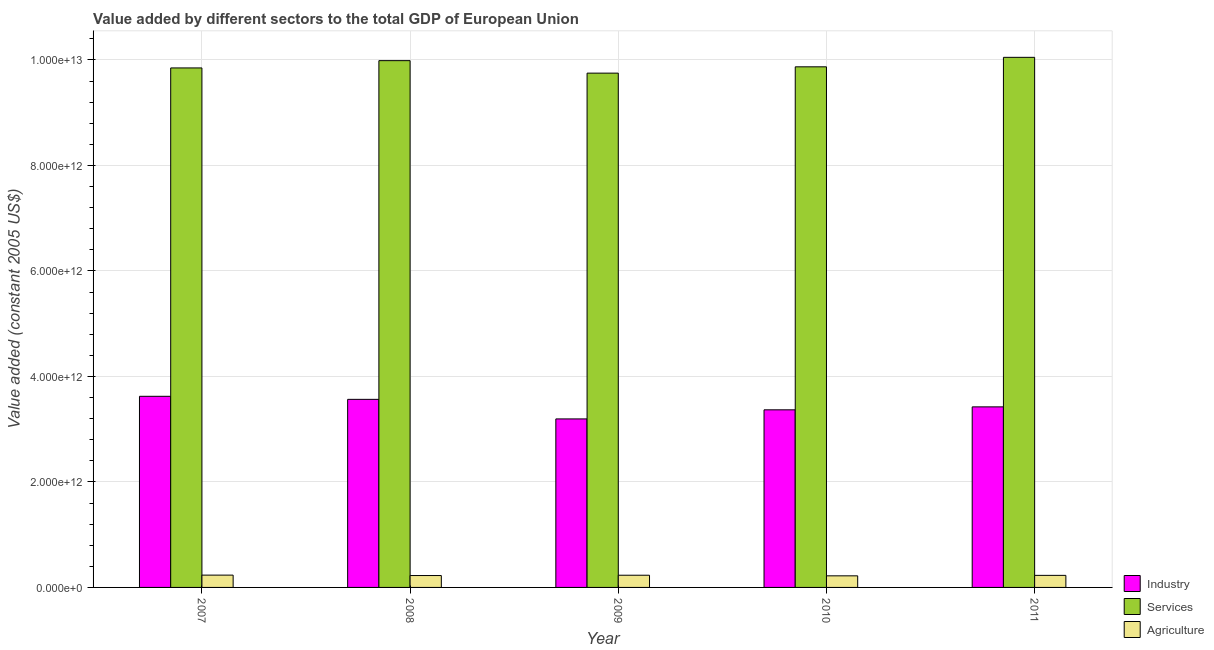Are the number of bars per tick equal to the number of legend labels?
Keep it short and to the point. Yes. How many bars are there on the 2nd tick from the left?
Make the answer very short. 3. What is the label of the 4th group of bars from the left?
Make the answer very short. 2010. What is the value added by industrial sector in 2009?
Provide a short and direct response. 3.19e+12. Across all years, what is the maximum value added by industrial sector?
Give a very brief answer. 3.62e+12. Across all years, what is the minimum value added by services?
Make the answer very short. 9.75e+12. In which year was the value added by agricultural sector minimum?
Keep it short and to the point. 2010. What is the total value added by agricultural sector in the graph?
Keep it short and to the point. 1.14e+12. What is the difference between the value added by industrial sector in 2007 and that in 2011?
Your answer should be compact. 2.00e+11. What is the difference between the value added by services in 2011 and the value added by agricultural sector in 2008?
Offer a very short reply. 6.28e+1. What is the average value added by services per year?
Keep it short and to the point. 9.90e+12. What is the ratio of the value added by industrial sector in 2008 to that in 2009?
Provide a succinct answer. 1.12. Is the difference between the value added by agricultural sector in 2008 and 2009 greater than the difference between the value added by services in 2008 and 2009?
Provide a short and direct response. No. What is the difference between the highest and the second highest value added by industrial sector?
Your answer should be compact. 5.77e+1. What is the difference between the highest and the lowest value added by agricultural sector?
Your response must be concise. 1.38e+1. In how many years, is the value added by industrial sector greater than the average value added by industrial sector taken over all years?
Your answer should be compact. 2. What does the 2nd bar from the left in 2009 represents?
Your response must be concise. Services. What does the 3rd bar from the right in 2009 represents?
Provide a short and direct response. Industry. Is it the case that in every year, the sum of the value added by industrial sector and value added by services is greater than the value added by agricultural sector?
Your answer should be compact. Yes. Are all the bars in the graph horizontal?
Your answer should be very brief. No. What is the difference between two consecutive major ticks on the Y-axis?
Ensure brevity in your answer.  2.00e+12. Are the values on the major ticks of Y-axis written in scientific E-notation?
Provide a succinct answer. Yes. Does the graph contain any zero values?
Make the answer very short. No. Where does the legend appear in the graph?
Provide a succinct answer. Bottom right. How are the legend labels stacked?
Ensure brevity in your answer.  Vertical. What is the title of the graph?
Give a very brief answer. Value added by different sectors to the total GDP of European Union. What is the label or title of the X-axis?
Your answer should be very brief. Year. What is the label or title of the Y-axis?
Your response must be concise. Value added (constant 2005 US$). What is the Value added (constant 2005 US$) of Industry in 2007?
Your response must be concise. 3.62e+12. What is the Value added (constant 2005 US$) in Services in 2007?
Give a very brief answer. 9.85e+12. What is the Value added (constant 2005 US$) in Agriculture in 2007?
Your answer should be very brief. 2.33e+11. What is the Value added (constant 2005 US$) of Industry in 2008?
Offer a terse response. 3.57e+12. What is the Value added (constant 2005 US$) of Services in 2008?
Your response must be concise. 9.99e+12. What is the Value added (constant 2005 US$) in Agriculture in 2008?
Ensure brevity in your answer.  2.25e+11. What is the Value added (constant 2005 US$) in Industry in 2009?
Your answer should be very brief. 3.19e+12. What is the Value added (constant 2005 US$) in Services in 2009?
Your response must be concise. 9.75e+12. What is the Value added (constant 2005 US$) in Agriculture in 2009?
Offer a terse response. 2.31e+11. What is the Value added (constant 2005 US$) in Industry in 2010?
Your answer should be very brief. 3.37e+12. What is the Value added (constant 2005 US$) of Services in 2010?
Provide a short and direct response. 9.87e+12. What is the Value added (constant 2005 US$) in Agriculture in 2010?
Offer a terse response. 2.20e+11. What is the Value added (constant 2005 US$) of Industry in 2011?
Keep it short and to the point. 3.42e+12. What is the Value added (constant 2005 US$) in Services in 2011?
Provide a succinct answer. 1.01e+13. What is the Value added (constant 2005 US$) of Agriculture in 2011?
Your answer should be very brief. 2.29e+11. Across all years, what is the maximum Value added (constant 2005 US$) in Industry?
Your answer should be very brief. 3.62e+12. Across all years, what is the maximum Value added (constant 2005 US$) of Services?
Ensure brevity in your answer.  1.01e+13. Across all years, what is the maximum Value added (constant 2005 US$) in Agriculture?
Offer a terse response. 2.33e+11. Across all years, what is the minimum Value added (constant 2005 US$) of Industry?
Keep it short and to the point. 3.19e+12. Across all years, what is the minimum Value added (constant 2005 US$) of Services?
Keep it short and to the point. 9.75e+12. Across all years, what is the minimum Value added (constant 2005 US$) in Agriculture?
Your answer should be very brief. 2.20e+11. What is the total Value added (constant 2005 US$) of Industry in the graph?
Ensure brevity in your answer.  1.72e+13. What is the total Value added (constant 2005 US$) in Services in the graph?
Keep it short and to the point. 4.95e+13. What is the total Value added (constant 2005 US$) in Agriculture in the graph?
Your answer should be very brief. 1.14e+12. What is the difference between the Value added (constant 2005 US$) of Industry in 2007 and that in 2008?
Make the answer very short. 5.77e+1. What is the difference between the Value added (constant 2005 US$) in Services in 2007 and that in 2008?
Your answer should be very brief. -1.38e+11. What is the difference between the Value added (constant 2005 US$) in Agriculture in 2007 and that in 2008?
Make the answer very short. 8.12e+09. What is the difference between the Value added (constant 2005 US$) in Industry in 2007 and that in 2009?
Keep it short and to the point. 4.29e+11. What is the difference between the Value added (constant 2005 US$) of Services in 2007 and that in 2009?
Make the answer very short. 9.87e+1. What is the difference between the Value added (constant 2005 US$) in Agriculture in 2007 and that in 2009?
Your answer should be compact. 2.23e+09. What is the difference between the Value added (constant 2005 US$) in Industry in 2007 and that in 2010?
Ensure brevity in your answer.  2.56e+11. What is the difference between the Value added (constant 2005 US$) in Services in 2007 and that in 2010?
Your answer should be very brief. -2.10e+1. What is the difference between the Value added (constant 2005 US$) of Agriculture in 2007 and that in 2010?
Keep it short and to the point. 1.38e+1. What is the difference between the Value added (constant 2005 US$) of Industry in 2007 and that in 2011?
Provide a short and direct response. 2.00e+11. What is the difference between the Value added (constant 2005 US$) of Services in 2007 and that in 2011?
Keep it short and to the point. -2.01e+11. What is the difference between the Value added (constant 2005 US$) in Agriculture in 2007 and that in 2011?
Provide a short and direct response. 4.87e+09. What is the difference between the Value added (constant 2005 US$) of Industry in 2008 and that in 2009?
Provide a succinct answer. 3.71e+11. What is the difference between the Value added (constant 2005 US$) of Services in 2008 and that in 2009?
Make the answer very short. 2.37e+11. What is the difference between the Value added (constant 2005 US$) of Agriculture in 2008 and that in 2009?
Keep it short and to the point. -5.89e+09. What is the difference between the Value added (constant 2005 US$) in Industry in 2008 and that in 2010?
Provide a short and direct response. 1.98e+11. What is the difference between the Value added (constant 2005 US$) of Services in 2008 and that in 2010?
Your response must be concise. 1.17e+11. What is the difference between the Value added (constant 2005 US$) of Agriculture in 2008 and that in 2010?
Offer a terse response. 5.66e+09. What is the difference between the Value added (constant 2005 US$) in Industry in 2008 and that in 2011?
Make the answer very short. 1.42e+11. What is the difference between the Value added (constant 2005 US$) in Services in 2008 and that in 2011?
Your answer should be compact. -6.28e+1. What is the difference between the Value added (constant 2005 US$) of Agriculture in 2008 and that in 2011?
Offer a terse response. -3.25e+09. What is the difference between the Value added (constant 2005 US$) of Industry in 2009 and that in 2010?
Your response must be concise. -1.72e+11. What is the difference between the Value added (constant 2005 US$) of Services in 2009 and that in 2010?
Provide a succinct answer. -1.20e+11. What is the difference between the Value added (constant 2005 US$) in Agriculture in 2009 and that in 2010?
Provide a succinct answer. 1.15e+1. What is the difference between the Value added (constant 2005 US$) of Industry in 2009 and that in 2011?
Make the answer very short. -2.28e+11. What is the difference between the Value added (constant 2005 US$) in Services in 2009 and that in 2011?
Your answer should be very brief. -3.00e+11. What is the difference between the Value added (constant 2005 US$) of Agriculture in 2009 and that in 2011?
Keep it short and to the point. 2.63e+09. What is the difference between the Value added (constant 2005 US$) in Industry in 2010 and that in 2011?
Keep it short and to the point. -5.60e+1. What is the difference between the Value added (constant 2005 US$) of Services in 2010 and that in 2011?
Ensure brevity in your answer.  -1.80e+11. What is the difference between the Value added (constant 2005 US$) in Agriculture in 2010 and that in 2011?
Provide a succinct answer. -8.91e+09. What is the difference between the Value added (constant 2005 US$) in Industry in 2007 and the Value added (constant 2005 US$) in Services in 2008?
Your response must be concise. -6.36e+12. What is the difference between the Value added (constant 2005 US$) in Industry in 2007 and the Value added (constant 2005 US$) in Agriculture in 2008?
Your response must be concise. 3.40e+12. What is the difference between the Value added (constant 2005 US$) of Services in 2007 and the Value added (constant 2005 US$) of Agriculture in 2008?
Your response must be concise. 9.62e+12. What is the difference between the Value added (constant 2005 US$) of Industry in 2007 and the Value added (constant 2005 US$) of Services in 2009?
Make the answer very short. -6.13e+12. What is the difference between the Value added (constant 2005 US$) of Industry in 2007 and the Value added (constant 2005 US$) of Agriculture in 2009?
Provide a short and direct response. 3.39e+12. What is the difference between the Value added (constant 2005 US$) in Services in 2007 and the Value added (constant 2005 US$) in Agriculture in 2009?
Provide a succinct answer. 9.62e+12. What is the difference between the Value added (constant 2005 US$) in Industry in 2007 and the Value added (constant 2005 US$) in Services in 2010?
Ensure brevity in your answer.  -6.25e+12. What is the difference between the Value added (constant 2005 US$) in Industry in 2007 and the Value added (constant 2005 US$) in Agriculture in 2010?
Your response must be concise. 3.40e+12. What is the difference between the Value added (constant 2005 US$) in Services in 2007 and the Value added (constant 2005 US$) in Agriculture in 2010?
Provide a short and direct response. 9.63e+12. What is the difference between the Value added (constant 2005 US$) of Industry in 2007 and the Value added (constant 2005 US$) of Services in 2011?
Your answer should be very brief. -6.43e+12. What is the difference between the Value added (constant 2005 US$) of Industry in 2007 and the Value added (constant 2005 US$) of Agriculture in 2011?
Your answer should be compact. 3.40e+12. What is the difference between the Value added (constant 2005 US$) in Services in 2007 and the Value added (constant 2005 US$) in Agriculture in 2011?
Offer a very short reply. 9.62e+12. What is the difference between the Value added (constant 2005 US$) in Industry in 2008 and the Value added (constant 2005 US$) in Services in 2009?
Provide a short and direct response. -6.18e+12. What is the difference between the Value added (constant 2005 US$) in Industry in 2008 and the Value added (constant 2005 US$) in Agriculture in 2009?
Your answer should be compact. 3.33e+12. What is the difference between the Value added (constant 2005 US$) in Services in 2008 and the Value added (constant 2005 US$) in Agriculture in 2009?
Your response must be concise. 9.76e+12. What is the difference between the Value added (constant 2005 US$) in Industry in 2008 and the Value added (constant 2005 US$) in Services in 2010?
Your answer should be very brief. -6.30e+12. What is the difference between the Value added (constant 2005 US$) of Industry in 2008 and the Value added (constant 2005 US$) of Agriculture in 2010?
Offer a terse response. 3.35e+12. What is the difference between the Value added (constant 2005 US$) in Services in 2008 and the Value added (constant 2005 US$) in Agriculture in 2010?
Make the answer very short. 9.77e+12. What is the difference between the Value added (constant 2005 US$) of Industry in 2008 and the Value added (constant 2005 US$) of Services in 2011?
Offer a terse response. -6.48e+12. What is the difference between the Value added (constant 2005 US$) in Industry in 2008 and the Value added (constant 2005 US$) in Agriculture in 2011?
Give a very brief answer. 3.34e+12. What is the difference between the Value added (constant 2005 US$) of Services in 2008 and the Value added (constant 2005 US$) of Agriculture in 2011?
Your answer should be compact. 9.76e+12. What is the difference between the Value added (constant 2005 US$) of Industry in 2009 and the Value added (constant 2005 US$) of Services in 2010?
Offer a very short reply. -6.68e+12. What is the difference between the Value added (constant 2005 US$) in Industry in 2009 and the Value added (constant 2005 US$) in Agriculture in 2010?
Make the answer very short. 2.98e+12. What is the difference between the Value added (constant 2005 US$) in Services in 2009 and the Value added (constant 2005 US$) in Agriculture in 2010?
Your response must be concise. 9.53e+12. What is the difference between the Value added (constant 2005 US$) in Industry in 2009 and the Value added (constant 2005 US$) in Services in 2011?
Your answer should be very brief. -6.86e+12. What is the difference between the Value added (constant 2005 US$) in Industry in 2009 and the Value added (constant 2005 US$) in Agriculture in 2011?
Your answer should be compact. 2.97e+12. What is the difference between the Value added (constant 2005 US$) of Services in 2009 and the Value added (constant 2005 US$) of Agriculture in 2011?
Keep it short and to the point. 9.52e+12. What is the difference between the Value added (constant 2005 US$) in Industry in 2010 and the Value added (constant 2005 US$) in Services in 2011?
Your answer should be very brief. -6.68e+12. What is the difference between the Value added (constant 2005 US$) in Industry in 2010 and the Value added (constant 2005 US$) in Agriculture in 2011?
Offer a terse response. 3.14e+12. What is the difference between the Value added (constant 2005 US$) in Services in 2010 and the Value added (constant 2005 US$) in Agriculture in 2011?
Make the answer very short. 9.64e+12. What is the average Value added (constant 2005 US$) of Industry per year?
Keep it short and to the point. 3.44e+12. What is the average Value added (constant 2005 US$) in Services per year?
Provide a succinct answer. 9.90e+12. What is the average Value added (constant 2005 US$) in Agriculture per year?
Ensure brevity in your answer.  2.28e+11. In the year 2007, what is the difference between the Value added (constant 2005 US$) of Industry and Value added (constant 2005 US$) of Services?
Offer a terse response. -6.23e+12. In the year 2007, what is the difference between the Value added (constant 2005 US$) in Industry and Value added (constant 2005 US$) in Agriculture?
Provide a succinct answer. 3.39e+12. In the year 2007, what is the difference between the Value added (constant 2005 US$) of Services and Value added (constant 2005 US$) of Agriculture?
Offer a very short reply. 9.62e+12. In the year 2008, what is the difference between the Value added (constant 2005 US$) of Industry and Value added (constant 2005 US$) of Services?
Your answer should be compact. -6.42e+12. In the year 2008, what is the difference between the Value added (constant 2005 US$) in Industry and Value added (constant 2005 US$) in Agriculture?
Offer a very short reply. 3.34e+12. In the year 2008, what is the difference between the Value added (constant 2005 US$) of Services and Value added (constant 2005 US$) of Agriculture?
Your answer should be very brief. 9.76e+12. In the year 2009, what is the difference between the Value added (constant 2005 US$) of Industry and Value added (constant 2005 US$) of Services?
Your answer should be very brief. -6.56e+12. In the year 2009, what is the difference between the Value added (constant 2005 US$) in Industry and Value added (constant 2005 US$) in Agriculture?
Give a very brief answer. 2.96e+12. In the year 2009, what is the difference between the Value added (constant 2005 US$) of Services and Value added (constant 2005 US$) of Agriculture?
Your answer should be very brief. 9.52e+12. In the year 2010, what is the difference between the Value added (constant 2005 US$) of Industry and Value added (constant 2005 US$) of Services?
Your answer should be compact. -6.50e+12. In the year 2010, what is the difference between the Value added (constant 2005 US$) in Industry and Value added (constant 2005 US$) in Agriculture?
Offer a terse response. 3.15e+12. In the year 2010, what is the difference between the Value added (constant 2005 US$) in Services and Value added (constant 2005 US$) in Agriculture?
Your answer should be very brief. 9.65e+12. In the year 2011, what is the difference between the Value added (constant 2005 US$) of Industry and Value added (constant 2005 US$) of Services?
Your response must be concise. -6.63e+12. In the year 2011, what is the difference between the Value added (constant 2005 US$) in Industry and Value added (constant 2005 US$) in Agriculture?
Provide a short and direct response. 3.19e+12. In the year 2011, what is the difference between the Value added (constant 2005 US$) of Services and Value added (constant 2005 US$) of Agriculture?
Your answer should be compact. 9.82e+12. What is the ratio of the Value added (constant 2005 US$) of Industry in 2007 to that in 2008?
Ensure brevity in your answer.  1.02. What is the ratio of the Value added (constant 2005 US$) of Services in 2007 to that in 2008?
Provide a short and direct response. 0.99. What is the ratio of the Value added (constant 2005 US$) of Agriculture in 2007 to that in 2008?
Provide a succinct answer. 1.04. What is the ratio of the Value added (constant 2005 US$) of Industry in 2007 to that in 2009?
Provide a short and direct response. 1.13. What is the ratio of the Value added (constant 2005 US$) of Services in 2007 to that in 2009?
Give a very brief answer. 1.01. What is the ratio of the Value added (constant 2005 US$) of Agriculture in 2007 to that in 2009?
Your answer should be very brief. 1.01. What is the ratio of the Value added (constant 2005 US$) of Industry in 2007 to that in 2010?
Give a very brief answer. 1.08. What is the ratio of the Value added (constant 2005 US$) of Services in 2007 to that in 2010?
Give a very brief answer. 1. What is the ratio of the Value added (constant 2005 US$) in Agriculture in 2007 to that in 2010?
Offer a very short reply. 1.06. What is the ratio of the Value added (constant 2005 US$) of Industry in 2007 to that in 2011?
Keep it short and to the point. 1.06. What is the ratio of the Value added (constant 2005 US$) in Agriculture in 2007 to that in 2011?
Make the answer very short. 1.02. What is the ratio of the Value added (constant 2005 US$) in Industry in 2008 to that in 2009?
Make the answer very short. 1.12. What is the ratio of the Value added (constant 2005 US$) of Services in 2008 to that in 2009?
Offer a very short reply. 1.02. What is the ratio of the Value added (constant 2005 US$) of Agriculture in 2008 to that in 2009?
Your answer should be very brief. 0.97. What is the ratio of the Value added (constant 2005 US$) in Industry in 2008 to that in 2010?
Provide a succinct answer. 1.06. What is the ratio of the Value added (constant 2005 US$) of Services in 2008 to that in 2010?
Give a very brief answer. 1.01. What is the ratio of the Value added (constant 2005 US$) of Agriculture in 2008 to that in 2010?
Offer a very short reply. 1.03. What is the ratio of the Value added (constant 2005 US$) of Industry in 2008 to that in 2011?
Your response must be concise. 1.04. What is the ratio of the Value added (constant 2005 US$) of Services in 2008 to that in 2011?
Your response must be concise. 0.99. What is the ratio of the Value added (constant 2005 US$) in Agriculture in 2008 to that in 2011?
Ensure brevity in your answer.  0.99. What is the ratio of the Value added (constant 2005 US$) of Industry in 2009 to that in 2010?
Your answer should be compact. 0.95. What is the ratio of the Value added (constant 2005 US$) of Services in 2009 to that in 2010?
Your answer should be compact. 0.99. What is the ratio of the Value added (constant 2005 US$) of Agriculture in 2009 to that in 2010?
Offer a very short reply. 1.05. What is the ratio of the Value added (constant 2005 US$) of Services in 2009 to that in 2011?
Make the answer very short. 0.97. What is the ratio of the Value added (constant 2005 US$) in Agriculture in 2009 to that in 2011?
Your answer should be very brief. 1.01. What is the ratio of the Value added (constant 2005 US$) in Industry in 2010 to that in 2011?
Offer a terse response. 0.98. What is the ratio of the Value added (constant 2005 US$) in Services in 2010 to that in 2011?
Your response must be concise. 0.98. What is the ratio of the Value added (constant 2005 US$) in Agriculture in 2010 to that in 2011?
Offer a very short reply. 0.96. What is the difference between the highest and the second highest Value added (constant 2005 US$) in Industry?
Your answer should be compact. 5.77e+1. What is the difference between the highest and the second highest Value added (constant 2005 US$) in Services?
Your answer should be compact. 6.28e+1. What is the difference between the highest and the second highest Value added (constant 2005 US$) of Agriculture?
Keep it short and to the point. 2.23e+09. What is the difference between the highest and the lowest Value added (constant 2005 US$) in Industry?
Offer a very short reply. 4.29e+11. What is the difference between the highest and the lowest Value added (constant 2005 US$) in Services?
Ensure brevity in your answer.  3.00e+11. What is the difference between the highest and the lowest Value added (constant 2005 US$) in Agriculture?
Provide a short and direct response. 1.38e+1. 